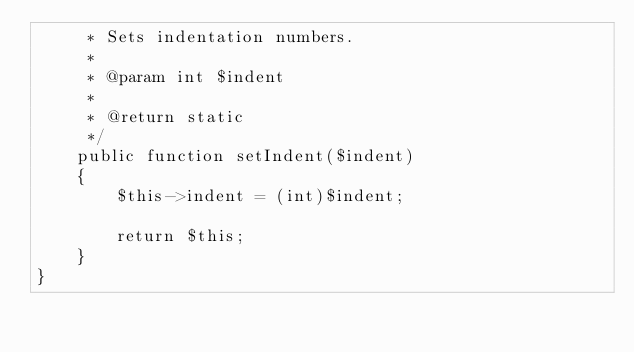<code> <loc_0><loc_0><loc_500><loc_500><_PHP_>     * Sets indentation numbers.
     *
     * @param int $indent
     *
     * @return static
     */
    public function setIndent($indent)
    {
        $this->indent = (int)$indent;

        return $this;
    }
}</code> 